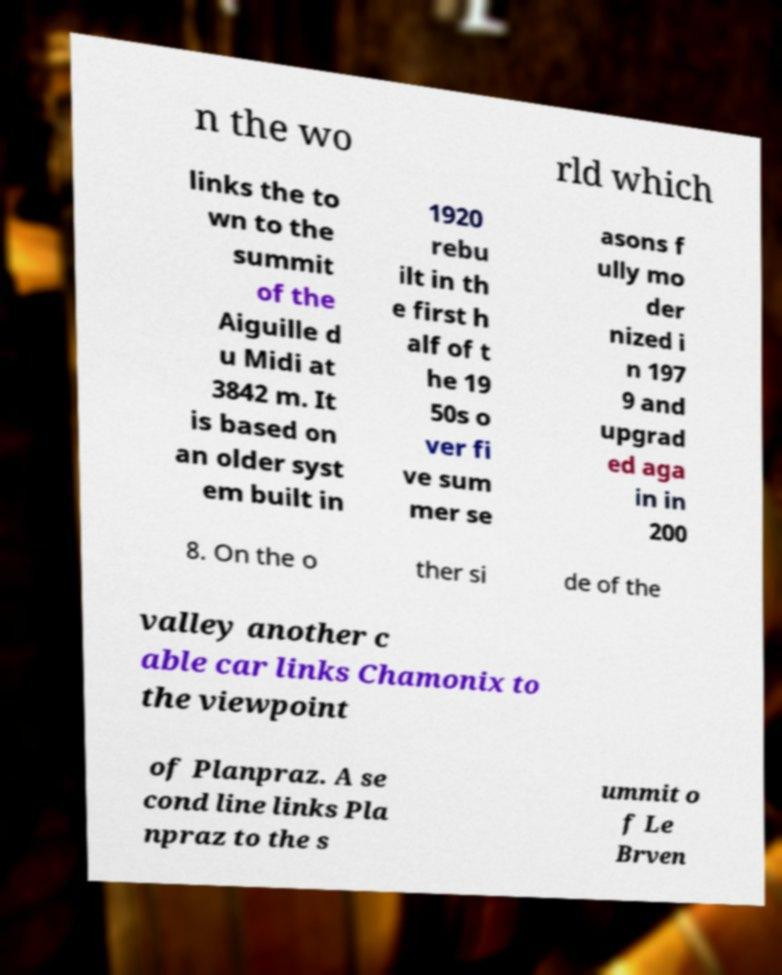Please identify and transcribe the text found in this image. n the wo rld which links the to wn to the summit of the Aiguille d u Midi at 3842 m. It is based on an older syst em built in 1920 rebu ilt in th e first h alf of t he 19 50s o ver fi ve sum mer se asons f ully mo der nized i n 197 9 and upgrad ed aga in in 200 8. On the o ther si de of the valley another c able car links Chamonix to the viewpoint of Planpraz. A se cond line links Pla npraz to the s ummit o f Le Brven 